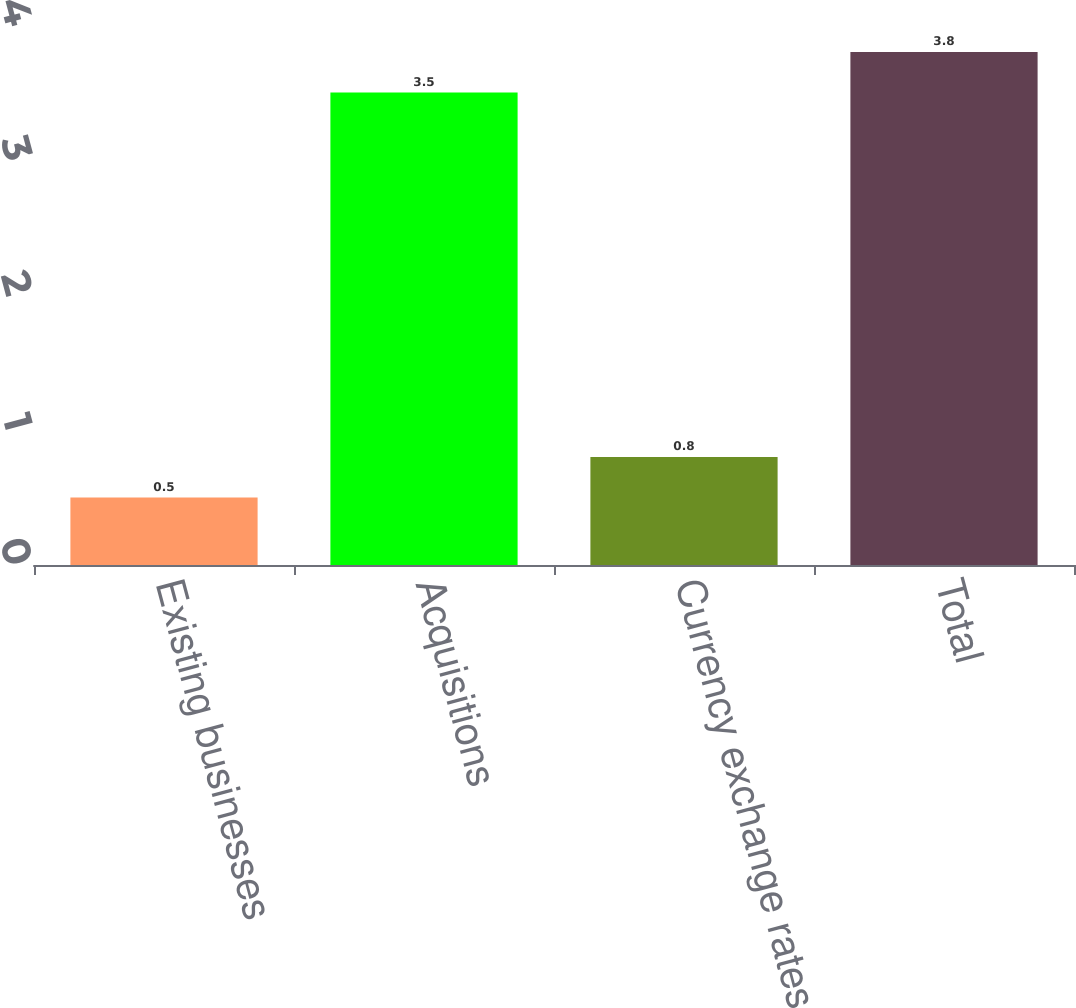Convert chart. <chart><loc_0><loc_0><loc_500><loc_500><bar_chart><fcel>Existing businesses<fcel>Acquisitions<fcel>Currency exchange rates<fcel>Total<nl><fcel>0.5<fcel>3.5<fcel>0.8<fcel>3.8<nl></chart> 